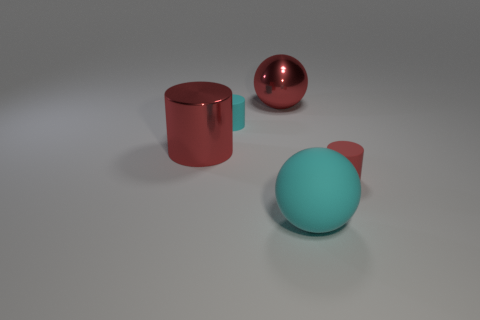What shape is the rubber thing that is both behind the cyan matte ball and in front of the large metallic cylinder?
Offer a terse response. Cylinder. How many other big matte objects have the same shape as the big cyan thing?
Offer a very short reply. 0. How many big red spheres are there?
Ensure brevity in your answer.  1. There is a rubber object that is both behind the large cyan object and to the right of the tiny cyan cylinder; what is its size?
Give a very brief answer. Small. What shape is the red thing that is the same size as the red ball?
Your response must be concise. Cylinder. Is there a matte ball left of the big shiny object left of the red metal sphere?
Your answer should be very brief. No. The other small rubber thing that is the same shape as the red rubber thing is what color?
Your response must be concise. Cyan. Does the large thing right of the large red sphere have the same color as the metal sphere?
Offer a very short reply. No. What number of objects are large balls on the right side of the red sphere or metal cylinders?
Provide a short and direct response. 2. There is a small thing that is on the left side of the thing behind the small thing on the left side of the matte sphere; what is it made of?
Offer a terse response. Rubber. 